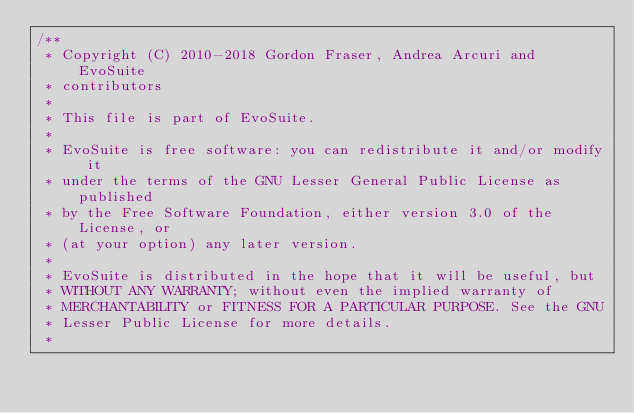Convert code to text. <code><loc_0><loc_0><loc_500><loc_500><_Java_>/**
 * Copyright (C) 2010-2018 Gordon Fraser, Andrea Arcuri and EvoSuite
 * contributors
 *
 * This file is part of EvoSuite.
 *
 * EvoSuite is free software: you can redistribute it and/or modify it
 * under the terms of the GNU Lesser General Public License as published
 * by the Free Software Foundation, either version 3.0 of the License, or
 * (at your option) any later version.
 *
 * EvoSuite is distributed in the hope that it will be useful, but
 * WITHOUT ANY WARRANTY; without even the implied warranty of
 * MERCHANTABILITY or FITNESS FOR A PARTICULAR PURPOSE. See the GNU
 * Lesser Public License for more details.
 *</code> 